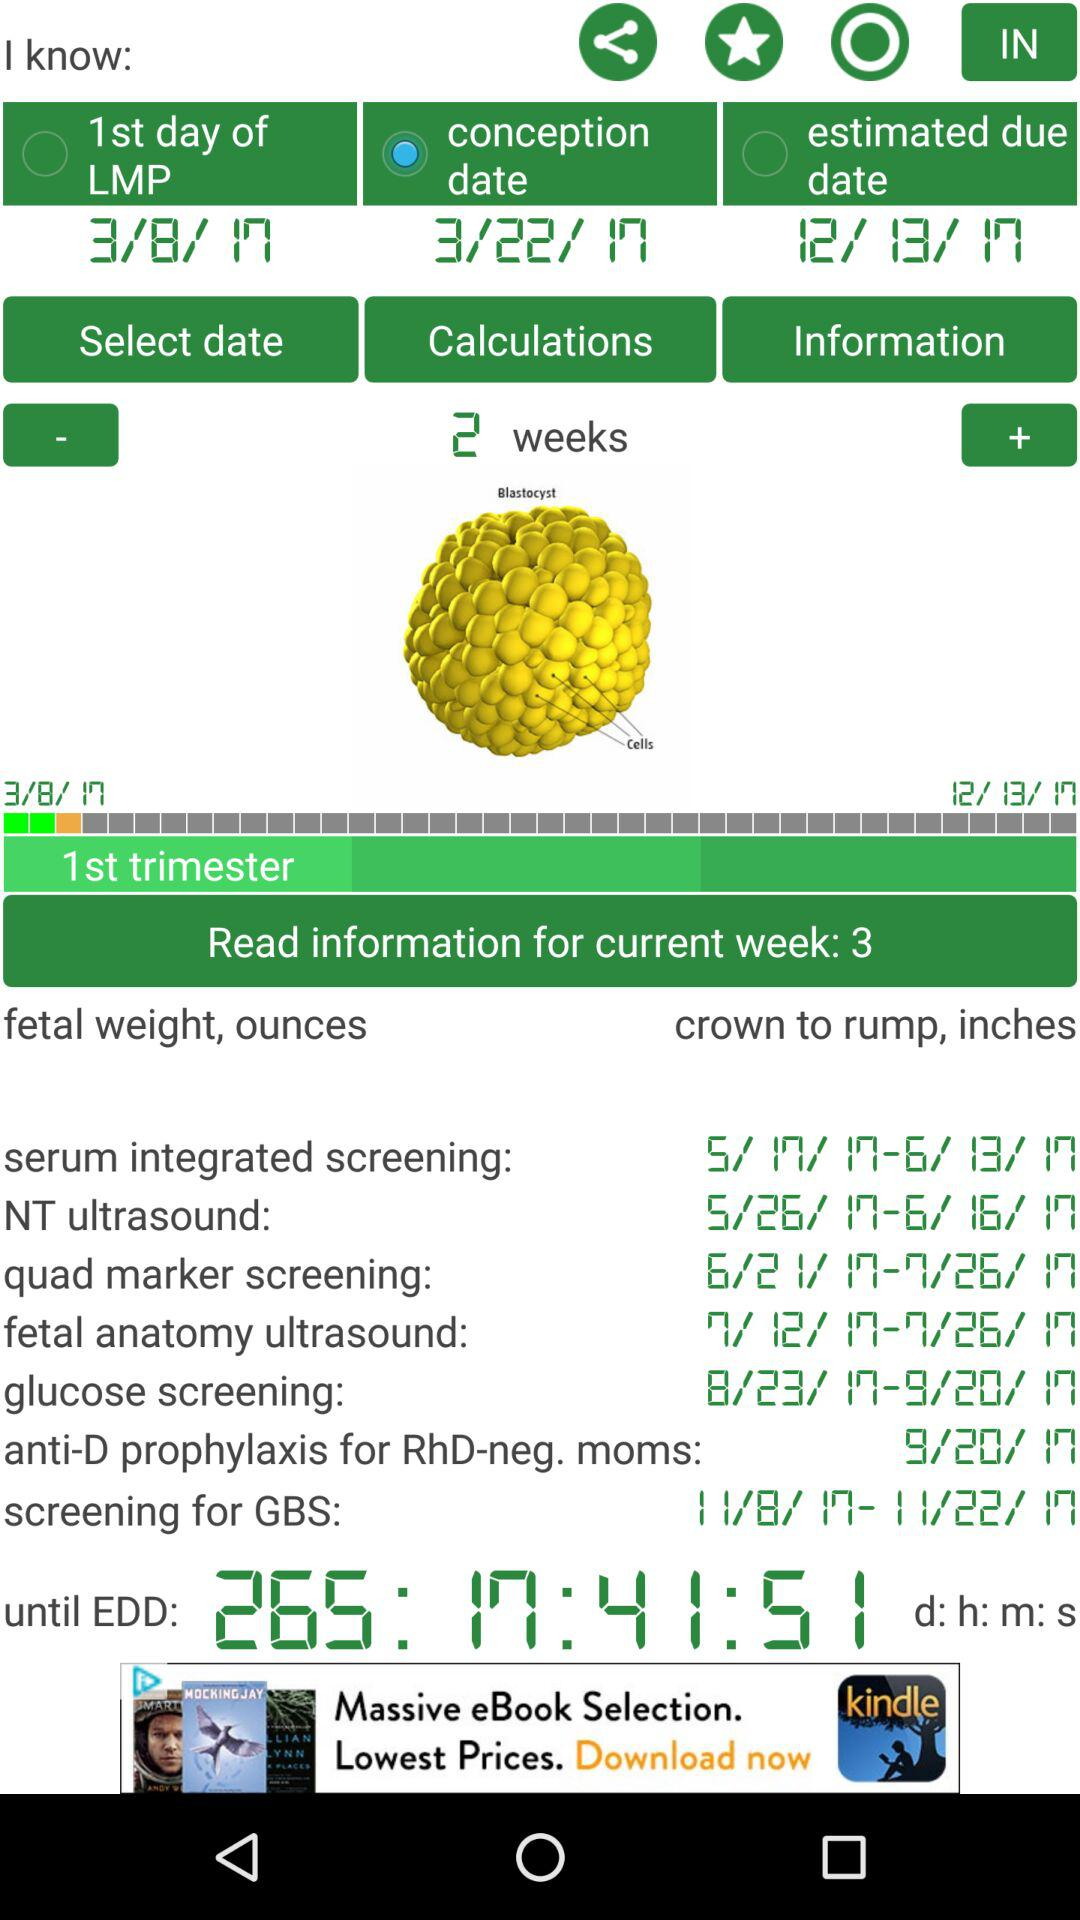Which option is selected? The selected option is "conception date". 